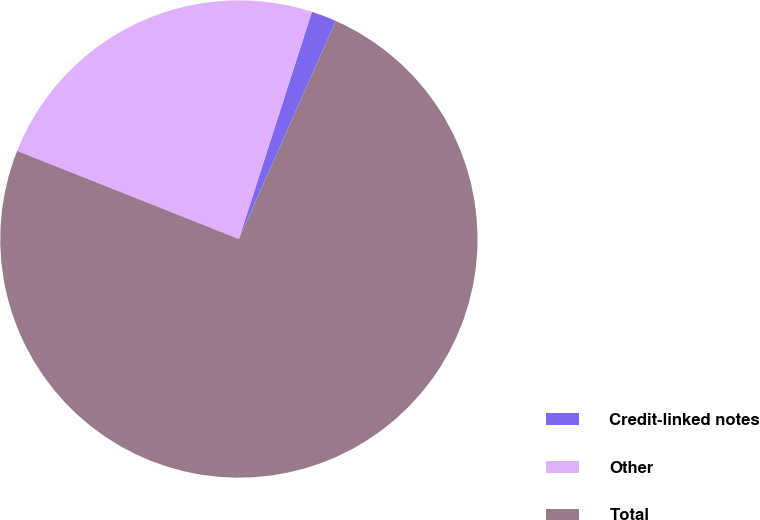Convert chart. <chart><loc_0><loc_0><loc_500><loc_500><pie_chart><fcel>Credit-linked notes<fcel>Other<fcel>Total<nl><fcel>1.71%<fcel>23.93%<fcel>74.36%<nl></chart> 